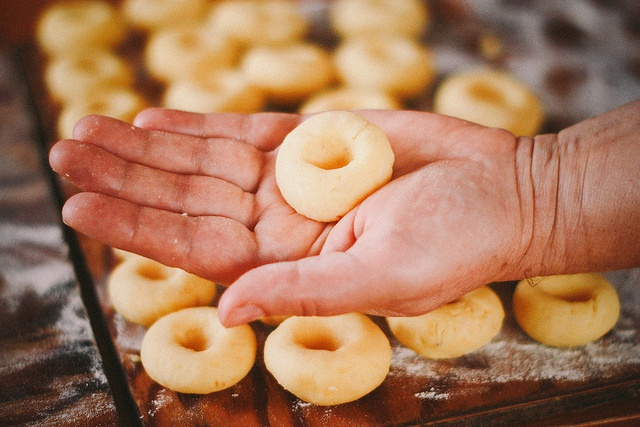Describe the objects in this image and their specific colors. I can see people in maroon, lightpink, and salmon tones, donut in maroon, tan, and beige tones, donut in maroon, tan, and orange tones, donut in maroon, tan, and orange tones, and donut in maroon, tan, olive, and orange tones in this image. 